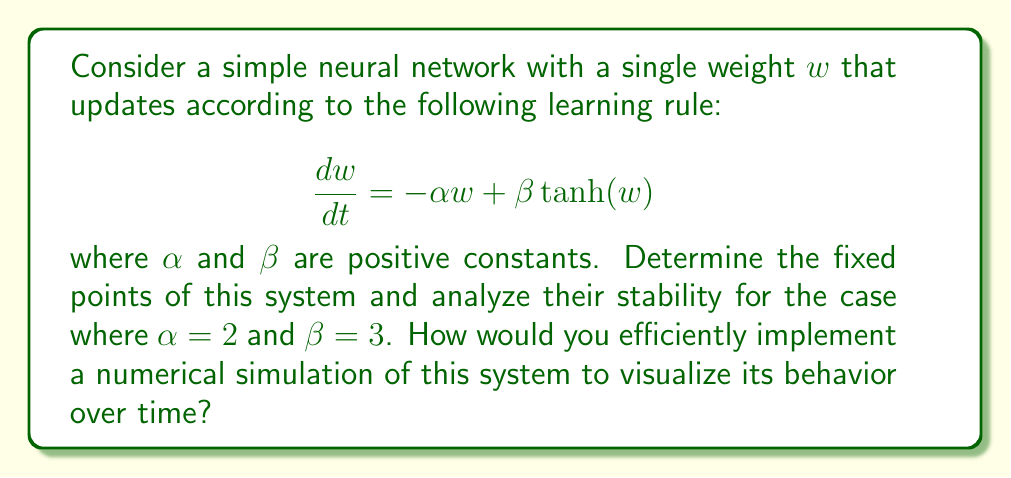Could you help me with this problem? 1. Find the fixed points:
   At fixed points, $\frac{dw}{dt} = 0$. So we solve:
   $$-\alpha w + \beta \tanh(w) = 0$$
   $$2w = 3\tanh(w)$$
   
   This equation has three solutions: $w = 0$ and two non-zero solutions (positive and negative).

2. Analyze stability:
   The stability is determined by the derivative of $\frac{dw}{dt}$ with respect to $w$ at each fixed point.
   $$\frac{d}{dw}\left(\frac{dw}{dt}\right) = -\alpha + \beta \text{sech}^2(w)$$
   
   At $w = 0$:
   $$-2 + 3 = 1 > 0$$
   So $w = 0$ is unstable.
   
   For the non-zero fixed points, we need to solve numerically. The positive fixed point is approximately at $w \approx 1.14619$. At this point:
   $$-2 + 3\text{sech}^2(1.14619) \approx -0.544 < 0$$
   So this fixed point is stable.
   
   By symmetry, the negative fixed point at $w \approx -1.14619$ is also stable.

3. Numerical simulation:
   To implement a numerical simulation, we can use the Euler method or a more advanced method like Runge-Kutta. In Python, we could use:

   ```python
   import numpy as np
   import matplotlib.pyplot as plt
   
   def dw_dt(w, alpha, beta):
       return -alpha * w + beta * np.tanh(w)
   
   def simulate(w0, t_max, dt, alpha, beta):
       t = np.arange(0, t_max, dt)
       w = np.zeros_like(t)
       w[0] = w0
       for i in range(1, len(t)):
           w[i] = w[i-1] + dw_dt(w[i-1], alpha, beta) * dt
       return t, w
   
   t, w = simulate(w0=0.5, t_max=10, dt=0.01, alpha=2, beta=3)
   plt.plot(t, w)
   plt.xlabel('Time')
   plt.ylabel('Weight')
   plt.title('Neural Network Weight Dynamics')
   plt.show()
   ```

   This code simulates the system's behavior over time and visualizes it, allowing us to observe the convergence to the stable fixed points.
Answer: Three fixed points: $w = 0$ (unstable), $w \approx \pm 1.14619$ (stable). Simulate using Euler method or Runge-Kutta in Python with NumPy and Matplotlib. 